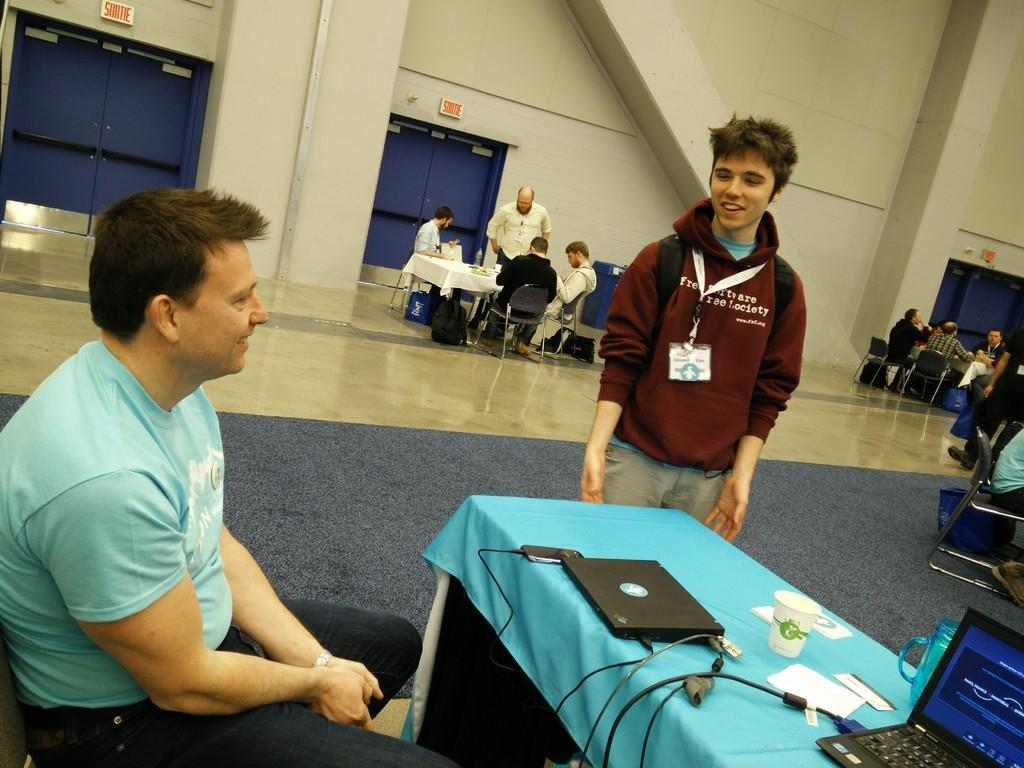How would you summarize this image in a sentence or two? In this image there are the group of persons sitting around the table on the right side, on the middle I can see there are Group of persons sitting around the table ,near the table I can see a backpack and there is a wall visible and there is a gate with blue color visible on the middle ,on the middle I can see there are the two persons one person standing on the floor ,his wearing a brown color jacket ,his mouth is open and another person sit in the chair his wearing a blue color shirt and this is smiling ,in front of him there is a table ,on the table there is a blue cloth kept on that ,and there is a laptop,jar ,paper kept on the table 